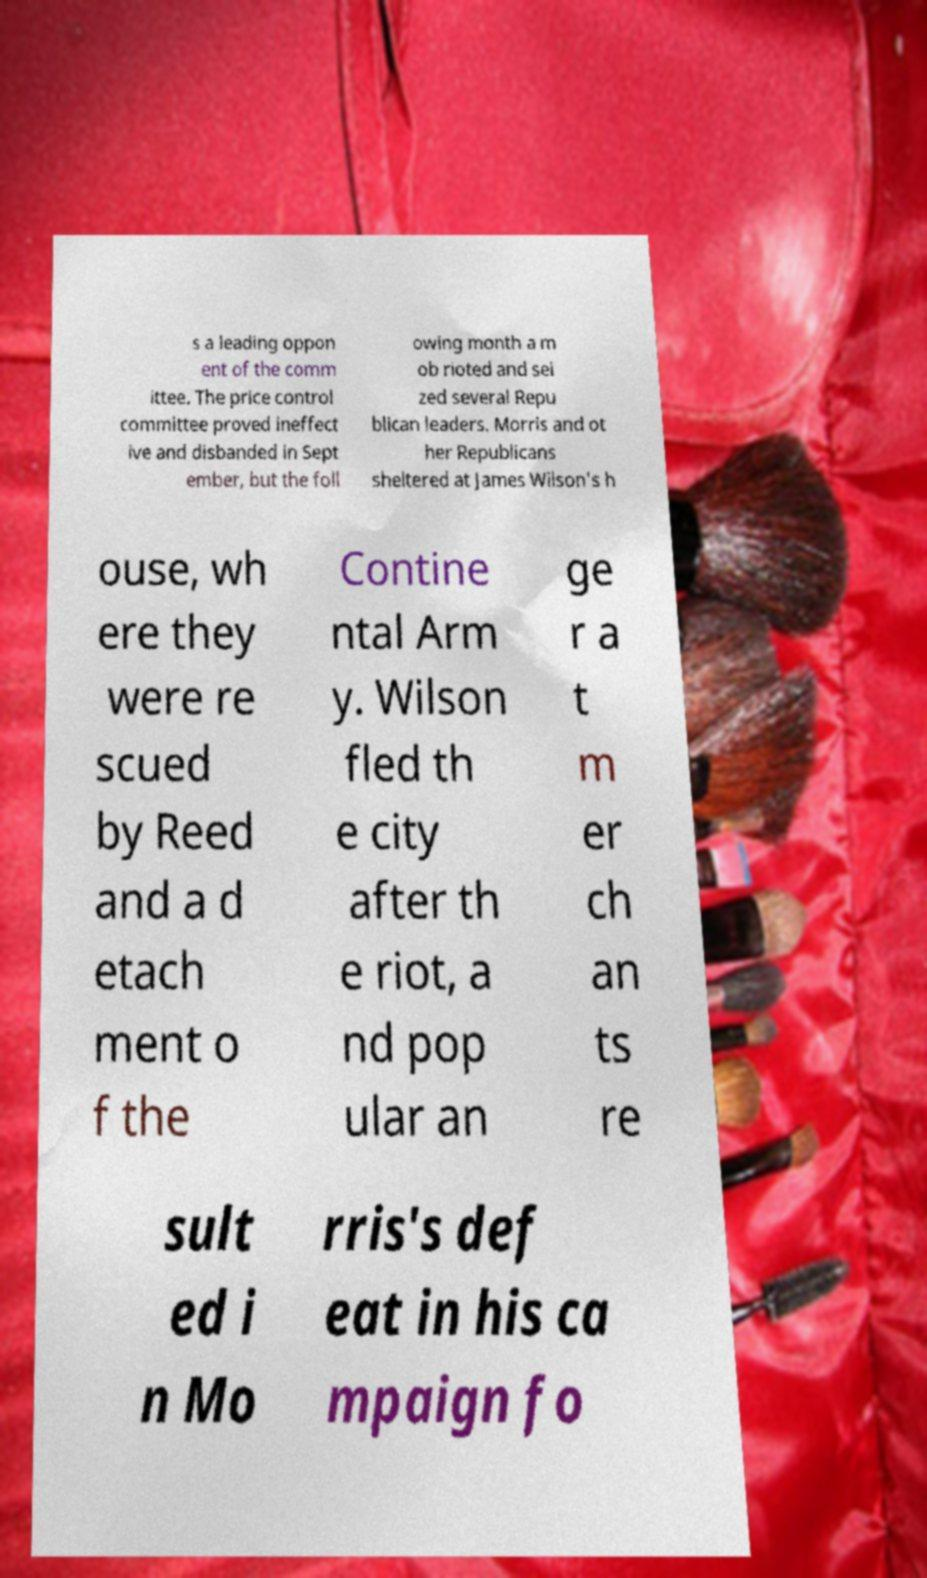Could you assist in decoding the text presented in this image and type it out clearly? s a leading oppon ent of the comm ittee. The price control committee proved ineffect ive and disbanded in Sept ember, but the foll owing month a m ob rioted and sei zed several Repu blican leaders. Morris and ot her Republicans sheltered at James Wilson's h ouse, wh ere they were re scued by Reed and a d etach ment o f the Contine ntal Arm y. Wilson fled th e city after th e riot, a nd pop ular an ge r a t m er ch an ts re sult ed i n Mo rris's def eat in his ca mpaign fo 